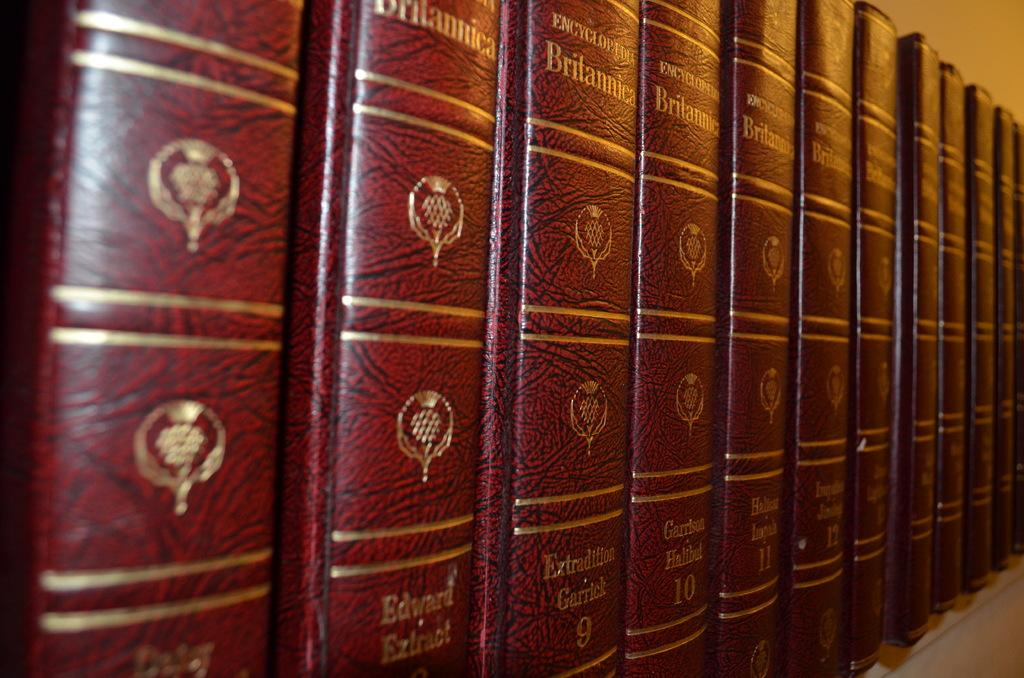<image>
Offer a succinct explanation of the picture presented. A shelf full of Encyclopaedia Britannicas in a row 